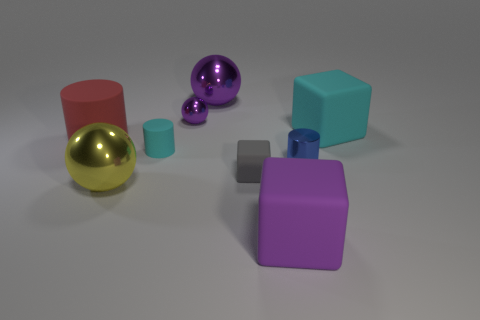What is the material of the tiny blue cylinder?
Ensure brevity in your answer.  Metal. Is the color of the big cube that is behind the purple rubber thing the same as the large metal sphere in front of the gray block?
Offer a terse response. No. Is the number of yellow metallic cylinders greater than the number of blue metal cylinders?
Make the answer very short. No. What number of rubber cubes have the same color as the tiny sphere?
Give a very brief answer. 1. What is the color of the other big metal object that is the same shape as the large yellow thing?
Your response must be concise. Purple. There is a purple thing that is both behind the large yellow metallic thing and on the right side of the tiny purple object; what is its material?
Give a very brief answer. Metal. Does the large block right of the tiny blue metallic thing have the same material as the sphere in front of the large cylinder?
Your response must be concise. No. The blue cylinder is what size?
Offer a terse response. Small. There is a gray thing that is the same shape as the purple matte thing; what is its size?
Give a very brief answer. Small. How many large yellow shiny balls are right of the big cyan cube?
Offer a terse response. 0. 